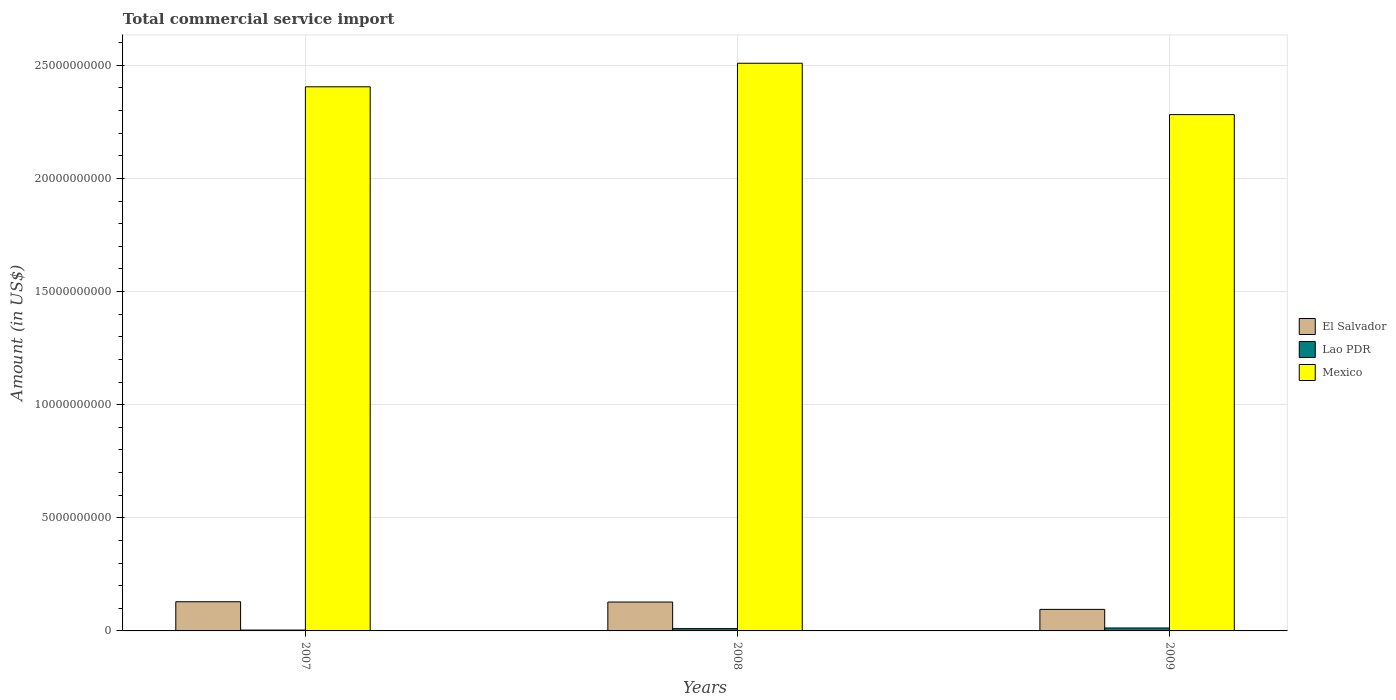How many different coloured bars are there?
Keep it short and to the point. 3. How many groups of bars are there?
Provide a short and direct response. 3. Are the number of bars per tick equal to the number of legend labels?
Give a very brief answer. Yes. How many bars are there on the 3rd tick from the left?
Your response must be concise. 3. In how many cases, is the number of bars for a given year not equal to the number of legend labels?
Offer a very short reply. 0. What is the total commercial service import in Mexico in 2008?
Provide a succinct answer. 2.51e+1. Across all years, what is the maximum total commercial service import in Lao PDR?
Your response must be concise. 1.30e+08. Across all years, what is the minimum total commercial service import in Mexico?
Provide a short and direct response. 2.28e+1. In which year was the total commercial service import in Lao PDR maximum?
Your response must be concise. 2009. What is the total total commercial service import in Lao PDR in the graph?
Make the answer very short. 2.70e+08. What is the difference between the total commercial service import in Mexico in 2008 and that in 2009?
Your response must be concise. 2.27e+09. What is the difference between the total commercial service import in Mexico in 2007 and the total commercial service import in Lao PDR in 2008?
Your answer should be very brief. 2.39e+1. What is the average total commercial service import in Mexico per year?
Keep it short and to the point. 2.40e+1. In the year 2007, what is the difference between the total commercial service import in Mexico and total commercial service import in El Salvador?
Your answer should be very brief. 2.28e+1. In how many years, is the total commercial service import in Mexico greater than 8000000000 US$?
Your answer should be compact. 3. What is the ratio of the total commercial service import in Lao PDR in 2007 to that in 2009?
Your answer should be compact. 0.29. Is the difference between the total commercial service import in Mexico in 2007 and 2009 greater than the difference between the total commercial service import in El Salvador in 2007 and 2009?
Offer a terse response. Yes. What is the difference between the highest and the second highest total commercial service import in El Salvador?
Make the answer very short. 1.27e+07. What is the difference between the highest and the lowest total commercial service import in El Salvador?
Your answer should be compact. 3.38e+08. What does the 3rd bar from the left in 2009 represents?
Offer a very short reply. Mexico. How many bars are there?
Provide a succinct answer. 9. What is the difference between two consecutive major ticks on the Y-axis?
Your response must be concise. 5.00e+09. Does the graph contain grids?
Your answer should be compact. Yes. Where does the legend appear in the graph?
Your answer should be compact. Center right. How are the legend labels stacked?
Offer a very short reply. Vertical. What is the title of the graph?
Provide a succinct answer. Total commercial service import. What is the label or title of the Y-axis?
Your answer should be very brief. Amount (in US$). What is the Amount (in US$) of El Salvador in 2007?
Your response must be concise. 1.29e+09. What is the Amount (in US$) in Lao PDR in 2007?
Provide a succinct answer. 3.77e+07. What is the Amount (in US$) in Mexico in 2007?
Offer a very short reply. 2.41e+1. What is the Amount (in US$) in El Salvador in 2008?
Offer a very short reply. 1.28e+09. What is the Amount (in US$) in Lao PDR in 2008?
Offer a very short reply. 1.02e+08. What is the Amount (in US$) of Mexico in 2008?
Ensure brevity in your answer.  2.51e+1. What is the Amount (in US$) in El Salvador in 2009?
Give a very brief answer. 9.52e+08. What is the Amount (in US$) of Lao PDR in 2009?
Your answer should be very brief. 1.30e+08. What is the Amount (in US$) of Mexico in 2009?
Your response must be concise. 2.28e+1. Across all years, what is the maximum Amount (in US$) of El Salvador?
Keep it short and to the point. 1.29e+09. Across all years, what is the maximum Amount (in US$) in Lao PDR?
Your response must be concise. 1.30e+08. Across all years, what is the maximum Amount (in US$) of Mexico?
Make the answer very short. 2.51e+1. Across all years, what is the minimum Amount (in US$) of El Salvador?
Provide a succinct answer. 9.52e+08. Across all years, what is the minimum Amount (in US$) in Lao PDR?
Your answer should be very brief. 3.77e+07. Across all years, what is the minimum Amount (in US$) of Mexico?
Ensure brevity in your answer.  2.28e+1. What is the total Amount (in US$) in El Salvador in the graph?
Provide a succinct answer. 3.52e+09. What is the total Amount (in US$) of Lao PDR in the graph?
Your answer should be very brief. 2.70e+08. What is the total Amount (in US$) of Mexico in the graph?
Give a very brief answer. 7.20e+1. What is the difference between the Amount (in US$) of El Salvador in 2007 and that in 2008?
Provide a short and direct response. 1.27e+07. What is the difference between the Amount (in US$) of Lao PDR in 2007 and that in 2008?
Your answer should be very brief. -6.46e+07. What is the difference between the Amount (in US$) of Mexico in 2007 and that in 2008?
Provide a short and direct response. -1.04e+09. What is the difference between the Amount (in US$) of El Salvador in 2007 and that in 2009?
Your answer should be very brief. 3.38e+08. What is the difference between the Amount (in US$) of Lao PDR in 2007 and that in 2009?
Your answer should be compact. -9.21e+07. What is the difference between the Amount (in US$) in Mexico in 2007 and that in 2009?
Provide a succinct answer. 1.23e+09. What is the difference between the Amount (in US$) of El Salvador in 2008 and that in 2009?
Keep it short and to the point. 3.25e+08. What is the difference between the Amount (in US$) of Lao PDR in 2008 and that in 2009?
Offer a terse response. -2.76e+07. What is the difference between the Amount (in US$) of Mexico in 2008 and that in 2009?
Your response must be concise. 2.27e+09. What is the difference between the Amount (in US$) in El Salvador in 2007 and the Amount (in US$) in Lao PDR in 2008?
Your answer should be compact. 1.19e+09. What is the difference between the Amount (in US$) of El Salvador in 2007 and the Amount (in US$) of Mexico in 2008?
Offer a very short reply. -2.38e+1. What is the difference between the Amount (in US$) of Lao PDR in 2007 and the Amount (in US$) of Mexico in 2008?
Offer a very short reply. -2.51e+1. What is the difference between the Amount (in US$) in El Salvador in 2007 and the Amount (in US$) in Lao PDR in 2009?
Keep it short and to the point. 1.16e+09. What is the difference between the Amount (in US$) of El Salvador in 2007 and the Amount (in US$) of Mexico in 2009?
Provide a succinct answer. -2.15e+1. What is the difference between the Amount (in US$) of Lao PDR in 2007 and the Amount (in US$) of Mexico in 2009?
Give a very brief answer. -2.28e+1. What is the difference between the Amount (in US$) of El Salvador in 2008 and the Amount (in US$) of Lao PDR in 2009?
Ensure brevity in your answer.  1.15e+09. What is the difference between the Amount (in US$) in El Salvador in 2008 and the Amount (in US$) in Mexico in 2009?
Your answer should be very brief. -2.15e+1. What is the difference between the Amount (in US$) in Lao PDR in 2008 and the Amount (in US$) in Mexico in 2009?
Keep it short and to the point. -2.27e+1. What is the average Amount (in US$) of El Salvador per year?
Offer a terse response. 1.17e+09. What is the average Amount (in US$) of Lao PDR per year?
Your response must be concise. 8.99e+07. What is the average Amount (in US$) in Mexico per year?
Your response must be concise. 2.40e+1. In the year 2007, what is the difference between the Amount (in US$) of El Salvador and Amount (in US$) of Lao PDR?
Your answer should be compact. 1.25e+09. In the year 2007, what is the difference between the Amount (in US$) of El Salvador and Amount (in US$) of Mexico?
Your answer should be very brief. -2.28e+1. In the year 2007, what is the difference between the Amount (in US$) in Lao PDR and Amount (in US$) in Mexico?
Provide a succinct answer. -2.40e+1. In the year 2008, what is the difference between the Amount (in US$) of El Salvador and Amount (in US$) of Lao PDR?
Your response must be concise. 1.18e+09. In the year 2008, what is the difference between the Amount (in US$) in El Salvador and Amount (in US$) in Mexico?
Your answer should be compact. -2.38e+1. In the year 2008, what is the difference between the Amount (in US$) of Lao PDR and Amount (in US$) of Mexico?
Keep it short and to the point. -2.50e+1. In the year 2009, what is the difference between the Amount (in US$) in El Salvador and Amount (in US$) in Lao PDR?
Offer a terse response. 8.22e+08. In the year 2009, what is the difference between the Amount (in US$) in El Salvador and Amount (in US$) in Mexico?
Ensure brevity in your answer.  -2.19e+1. In the year 2009, what is the difference between the Amount (in US$) of Lao PDR and Amount (in US$) of Mexico?
Provide a succinct answer. -2.27e+1. What is the ratio of the Amount (in US$) in El Salvador in 2007 to that in 2008?
Your answer should be compact. 1.01. What is the ratio of the Amount (in US$) in Lao PDR in 2007 to that in 2008?
Keep it short and to the point. 0.37. What is the ratio of the Amount (in US$) of Mexico in 2007 to that in 2008?
Make the answer very short. 0.96. What is the ratio of the Amount (in US$) of El Salvador in 2007 to that in 2009?
Offer a terse response. 1.35. What is the ratio of the Amount (in US$) of Lao PDR in 2007 to that in 2009?
Keep it short and to the point. 0.29. What is the ratio of the Amount (in US$) of Mexico in 2007 to that in 2009?
Your response must be concise. 1.05. What is the ratio of the Amount (in US$) of El Salvador in 2008 to that in 2009?
Your response must be concise. 1.34. What is the ratio of the Amount (in US$) of Lao PDR in 2008 to that in 2009?
Provide a short and direct response. 0.79. What is the ratio of the Amount (in US$) of Mexico in 2008 to that in 2009?
Offer a terse response. 1.1. What is the difference between the highest and the second highest Amount (in US$) of El Salvador?
Offer a terse response. 1.27e+07. What is the difference between the highest and the second highest Amount (in US$) in Lao PDR?
Your response must be concise. 2.76e+07. What is the difference between the highest and the second highest Amount (in US$) of Mexico?
Make the answer very short. 1.04e+09. What is the difference between the highest and the lowest Amount (in US$) of El Salvador?
Make the answer very short. 3.38e+08. What is the difference between the highest and the lowest Amount (in US$) of Lao PDR?
Offer a terse response. 9.21e+07. What is the difference between the highest and the lowest Amount (in US$) of Mexico?
Provide a succinct answer. 2.27e+09. 